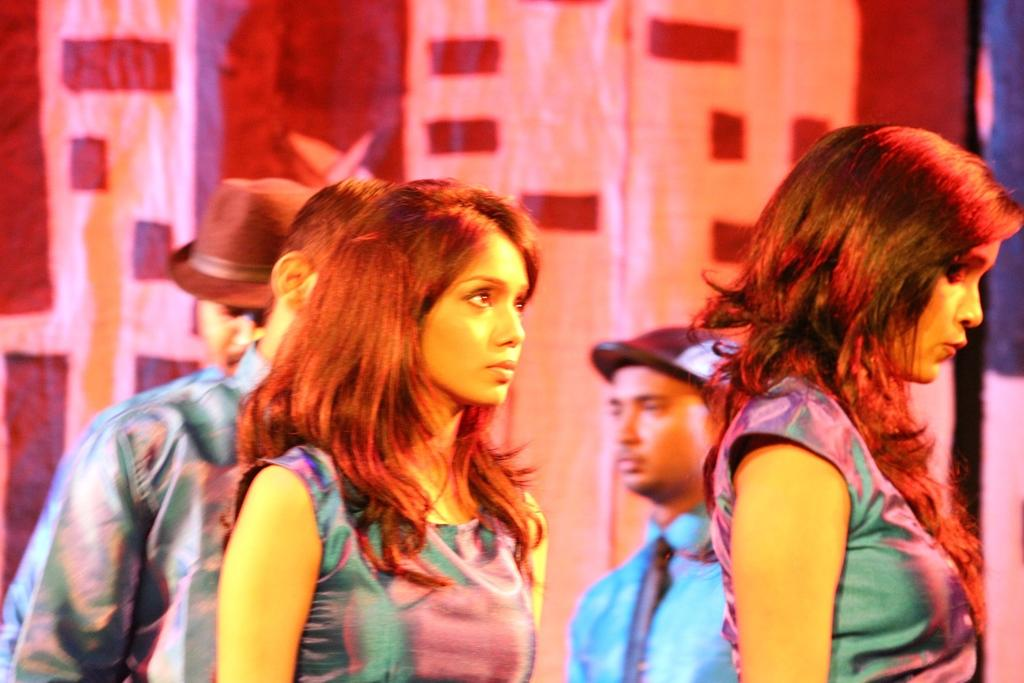Who or what can be seen in the image? There are people in the image. Can you describe the background of the image? The background of the image is blurry. What else is present in the background of the image? There are banners in the background of the image. What type of fog can be seen in the image? There is no fog present in the image; the background is blurry, but it is not due to fog. 